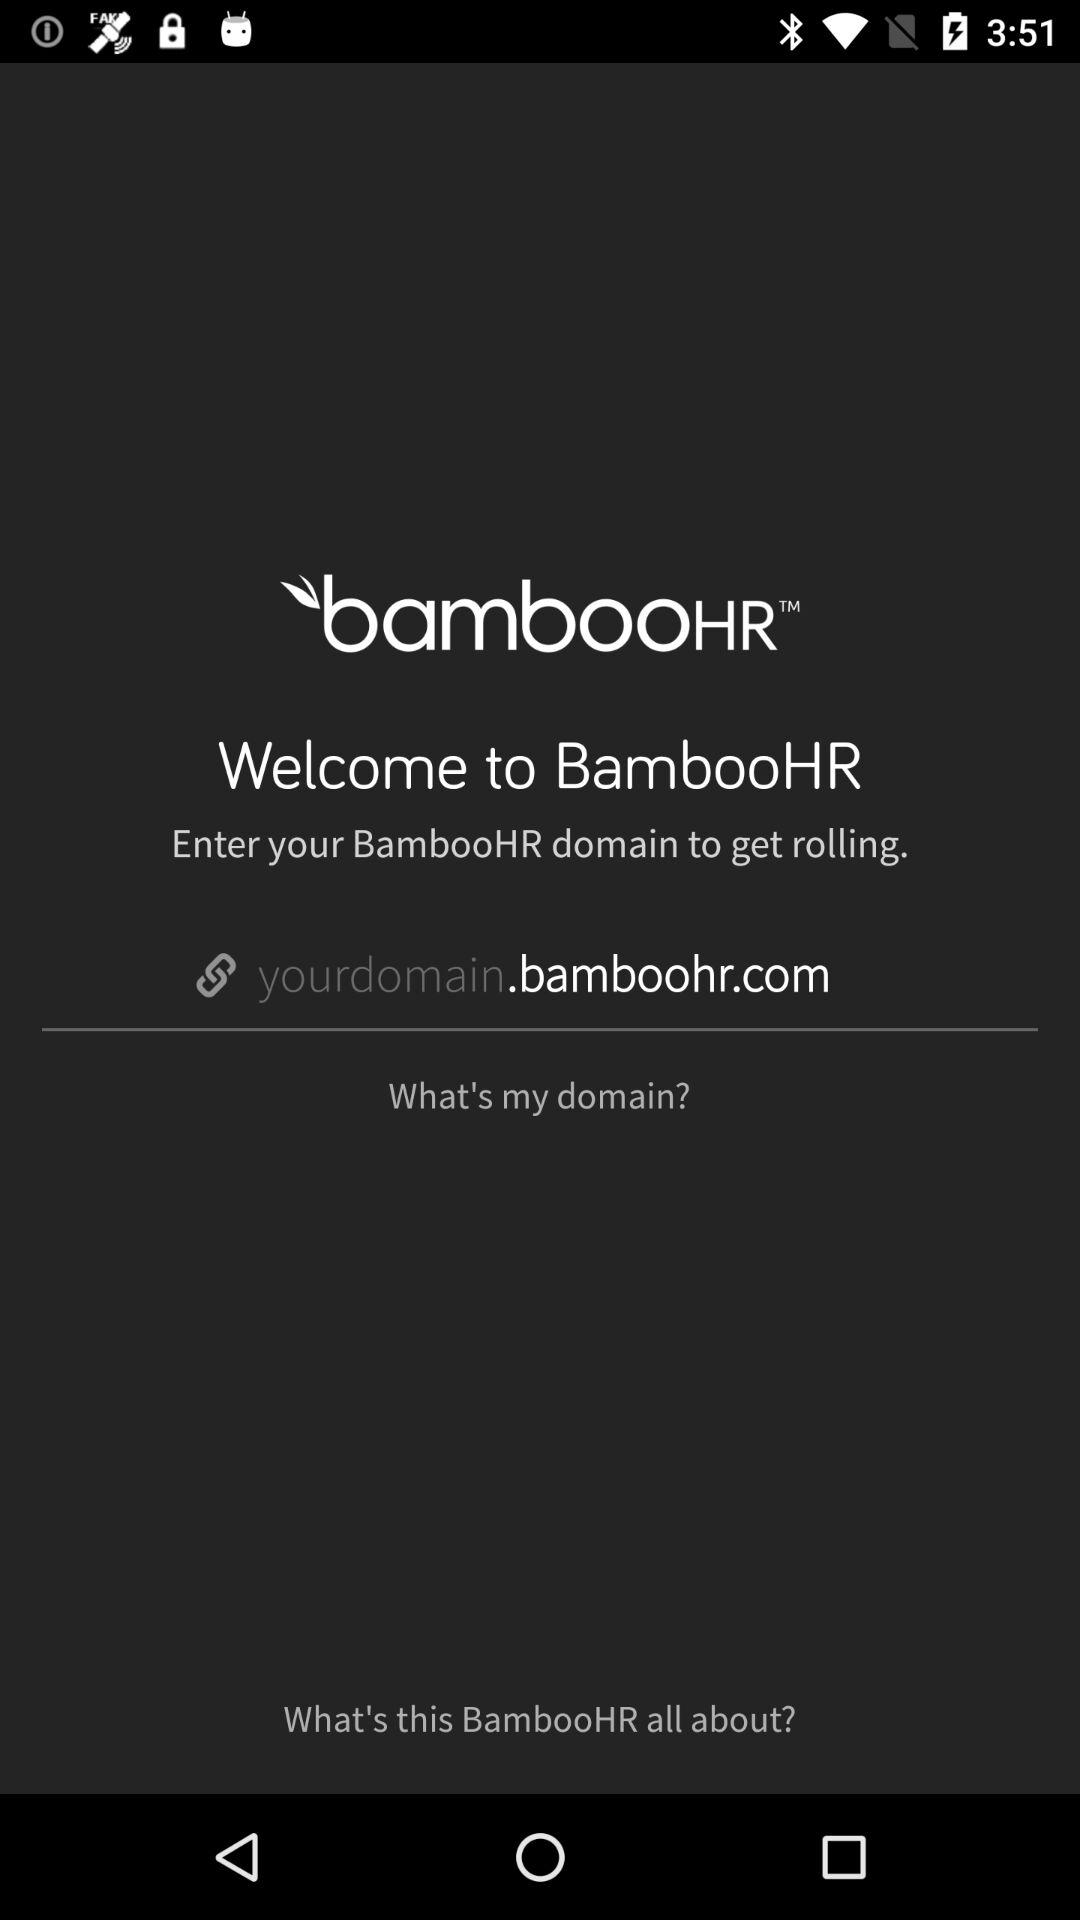What is the application name? The application name is "bambooHR". 